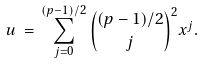Convert formula to latex. <formula><loc_0><loc_0><loc_500><loc_500>u \, = \, \sum _ { j = 0 } ^ { ( p - 1 ) / 2 } \binom { ( p - 1 ) / 2 } { j } ^ { 2 } x ^ { j } .</formula> 